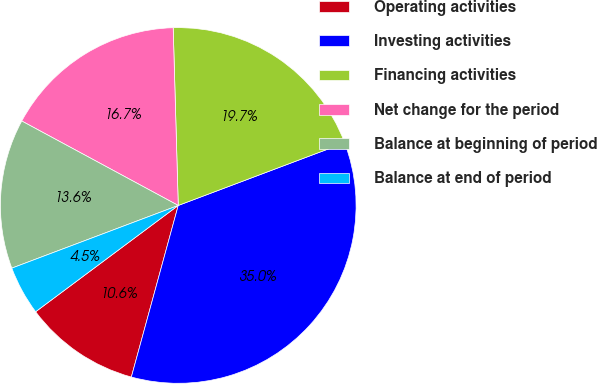Convert chart to OTSL. <chart><loc_0><loc_0><loc_500><loc_500><pie_chart><fcel>Operating activities<fcel>Investing activities<fcel>Financing activities<fcel>Net change for the period<fcel>Balance at beginning of period<fcel>Balance at end of period<nl><fcel>10.56%<fcel>34.98%<fcel>19.72%<fcel>16.67%<fcel>13.61%<fcel>4.46%<nl></chart> 